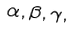<formula> <loc_0><loc_0><loc_500><loc_500>\alpha , \beta , \gamma ,</formula> 